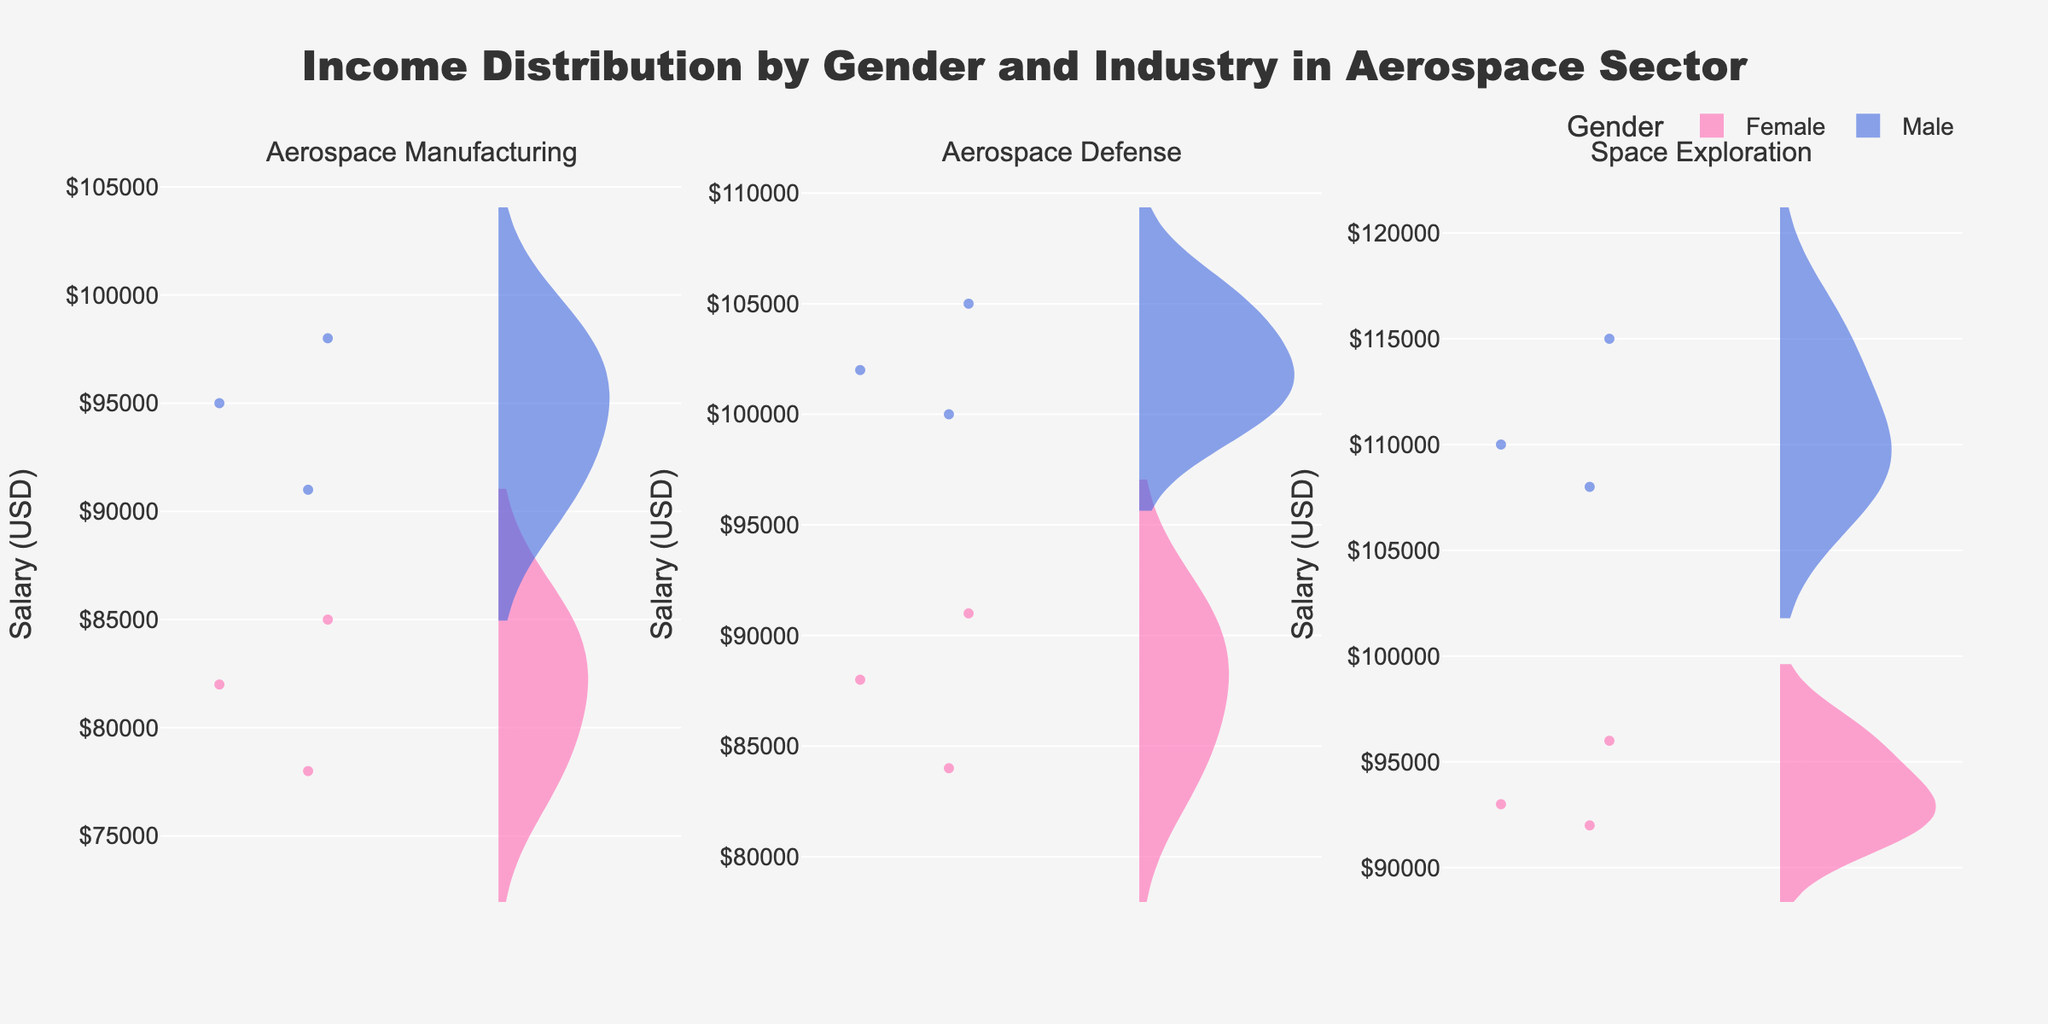What is the title of the figure? The title is located at the top of the figure and reads "Income Distribution by Gender and Industry in Aerospace Sector."
Answer: Income Distribution by Gender and Industry in Aerospace Sector Which gender has the higher income distribution in Aerospace Manufacturing? By examining the density plots in the Aerospace Manufacturing subplot, it is clear that the male distribution is higher as it is mostly in the range of $91,000 to $98,000, whereas the female distribution is slightly lower.
Answer: Male What is the color used to represent female income distribution? The color associated with the female distribution in the plots is pink, indicating a stronger visual distinguisher.
Answer: Pink What is the average salary for females in Space Exploration? The salary for females in Space Exploration is represented by three values: $93,000, $96,000, and $92,000. Adding these values gives $281,000, and dividing by the 3 data points provides the average: 281,000/3.
Answer: $93,667 Which industry shows the highest mean salary for males? By observing the mean line in the three subplots for males, the Space Exploration subplot shows the highest mean line, indicating the highest mean salary.
Answer: Space Exploration How many data points are represented for females in Aerospace Defense? The violin plot for females in Aerospace Defense shows three scatter points, meaning there are three data points.
Answer: 3 Compare the salary range for males and females in Aerospace Defense. The salary range for females is between $84,000 and $91,000, while for males, it is between $100,000 and $105,000. Thus, males have a higher salary range than females in Aerospace Defense.
Answer: Males have a higher range What is the median salary for males in Aerospace Manufacturing? The median salary is the middle value when the data points are ordered. For males in Aerospace Manufacturing, the ordered values are $91,000, $95,000, and $98,000, making the median $95,000.
Answer: $95,000 In which industry do both genders have the smallest salary gap? By comparing the overlapping regions of the density plots, the Aerospace Manufacturing industry has the smallest salary gap where some female salaries reach into the male salary range.
Answer: Aerospace Manufacturing 